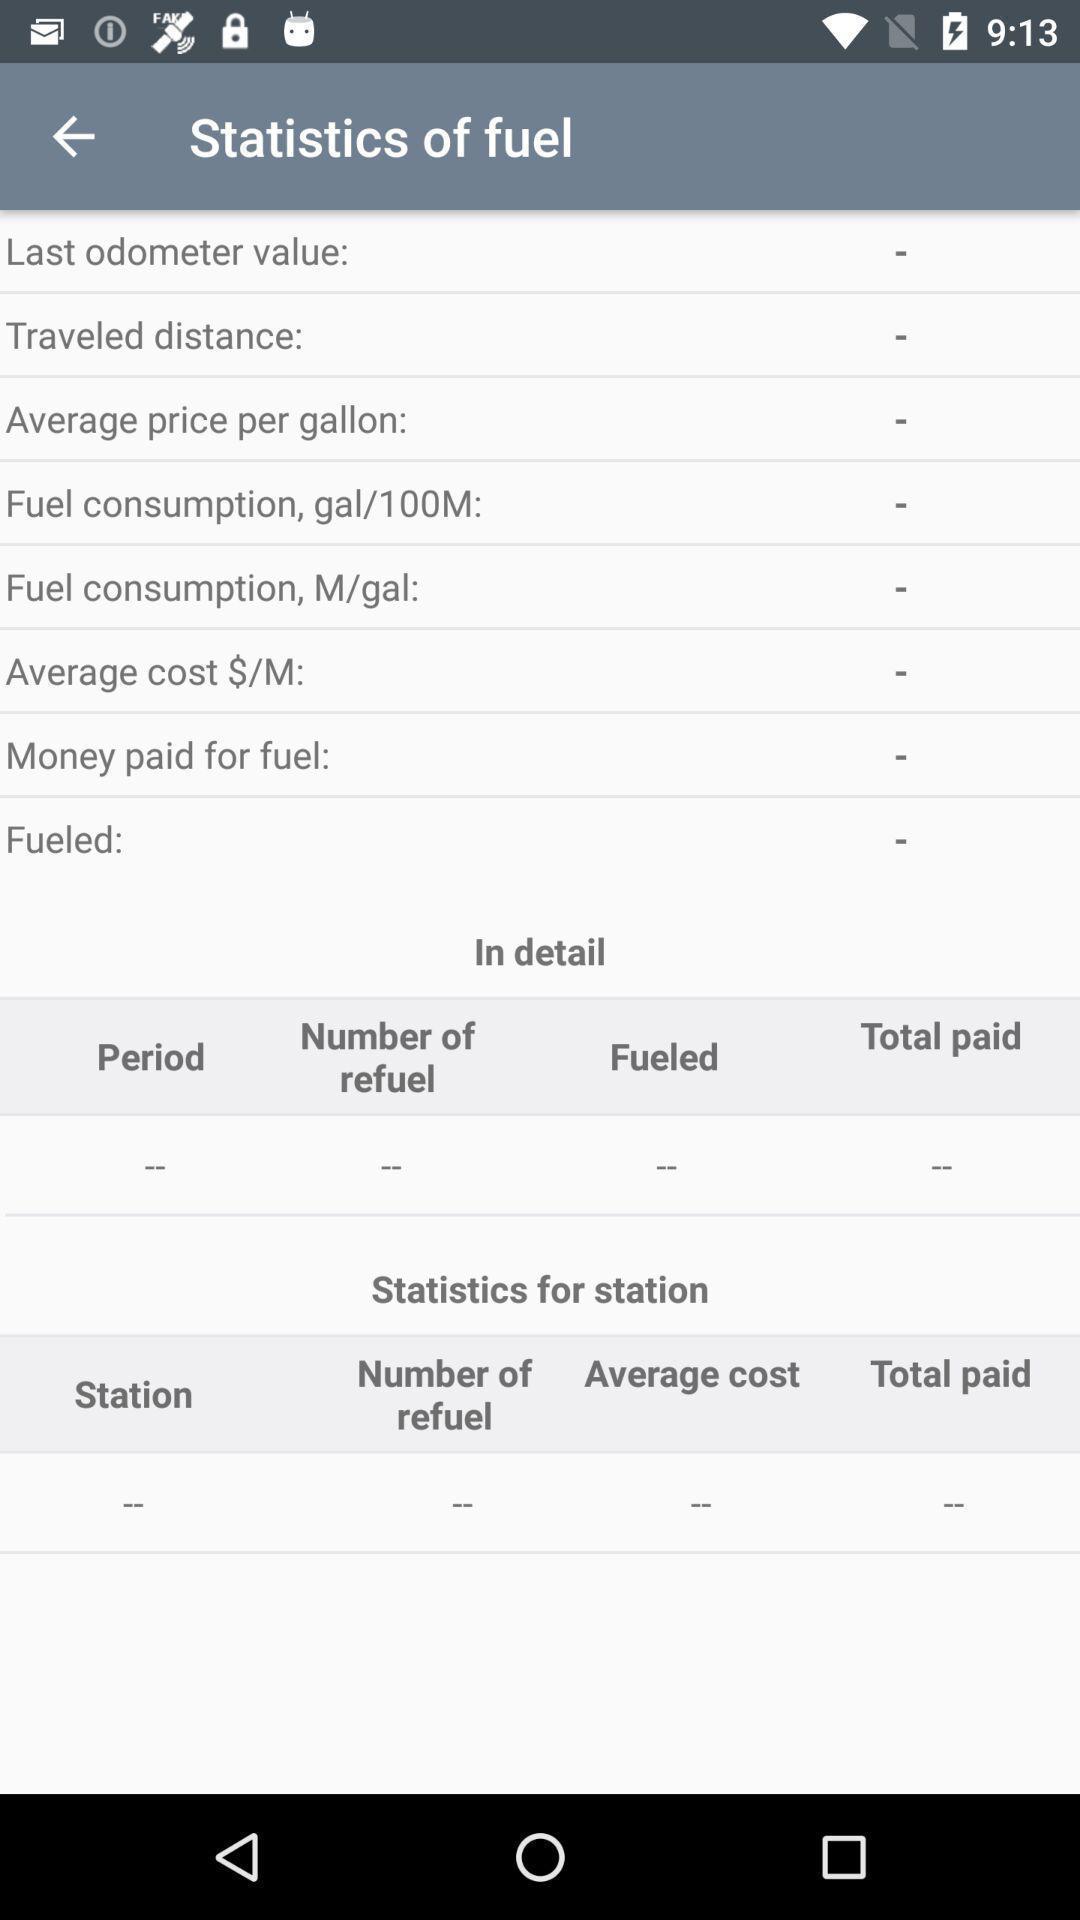Summarize the main components in this picture. Page showing options for fuel information. 